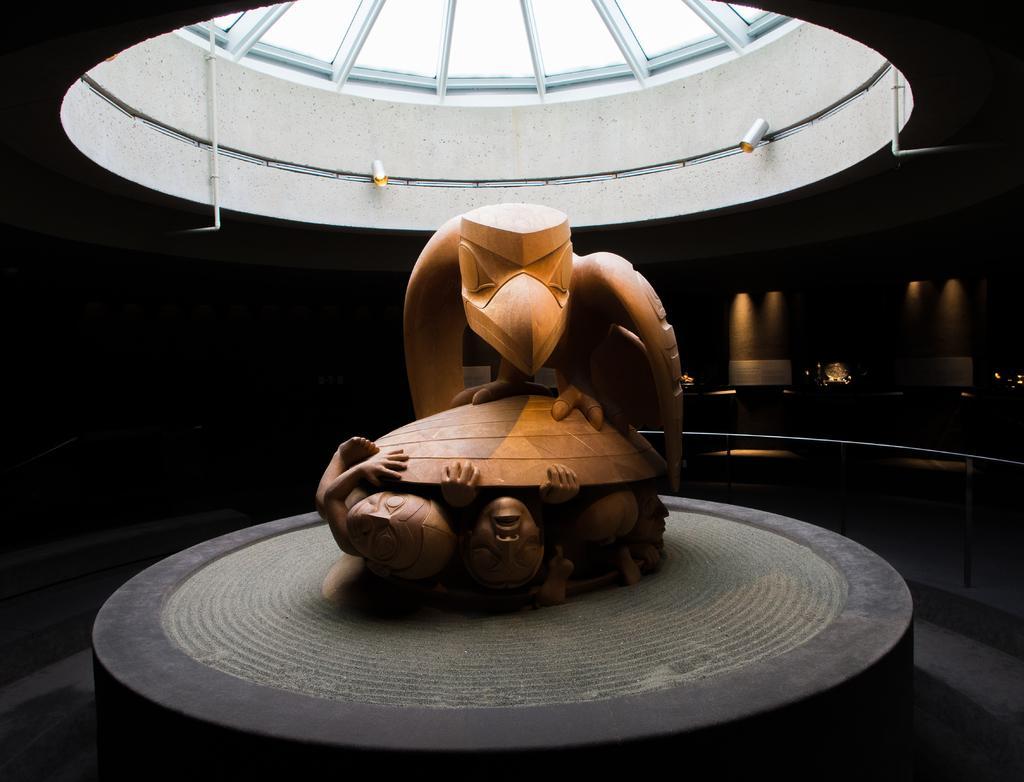How would you summarize this image in a sentence or two? In this image in the center there is a sculpture, and at the bottom it looks like a table. And at the top there is roof and cameras and pipe, and in the background there are lights, railing and some objects. At the bottom there is floor. 